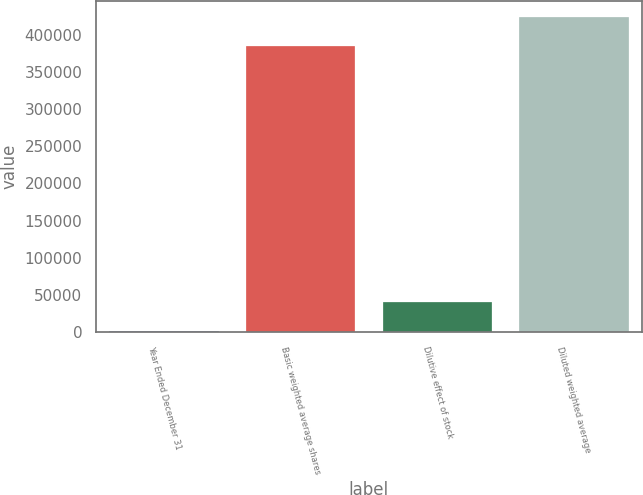<chart> <loc_0><loc_0><loc_500><loc_500><bar_chart><fcel>Year Ended December 31<fcel>Basic weighted average shares<fcel>Dilutive effect of stock<fcel>Diluted weighted average<nl><fcel>2009<fcel>385475<fcel>40600.4<fcel>424066<nl></chart> 